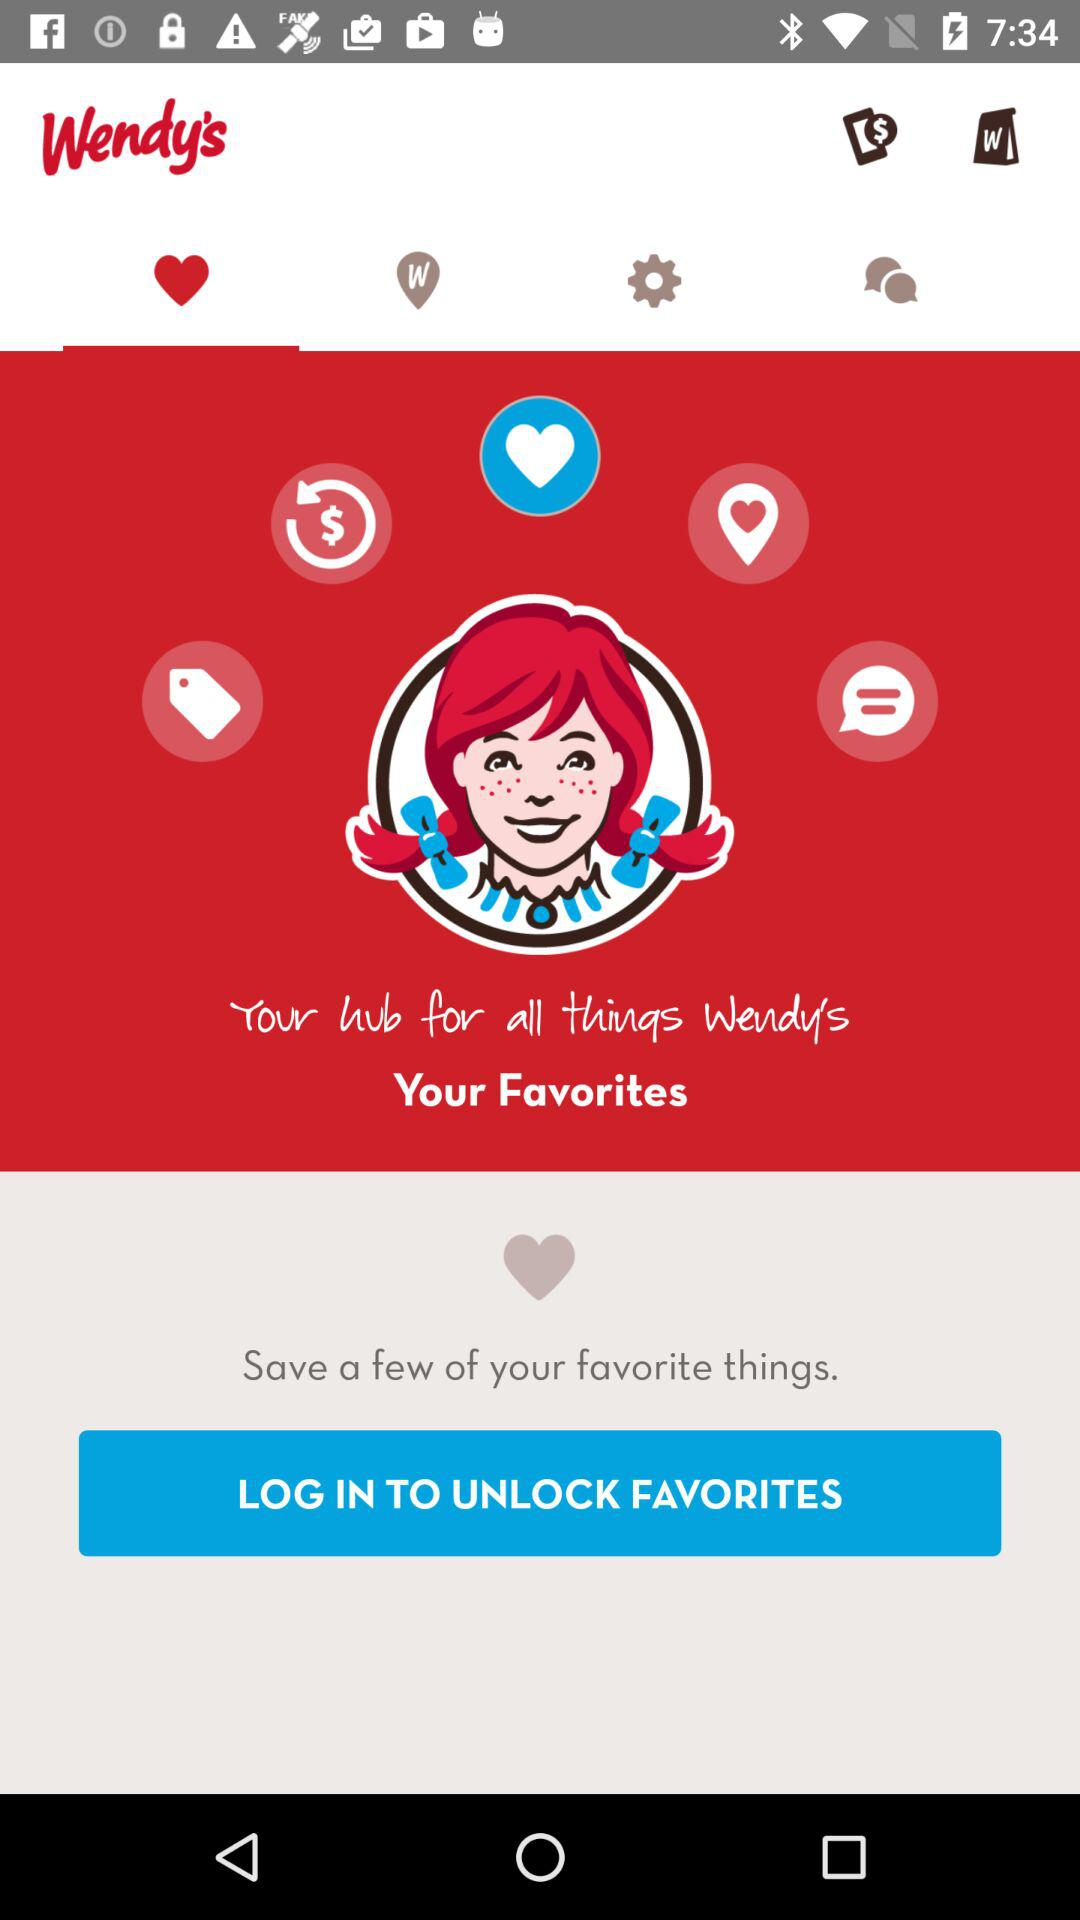What do I have to do to unlock my favorites? You have to log in to unlock your favorites. 